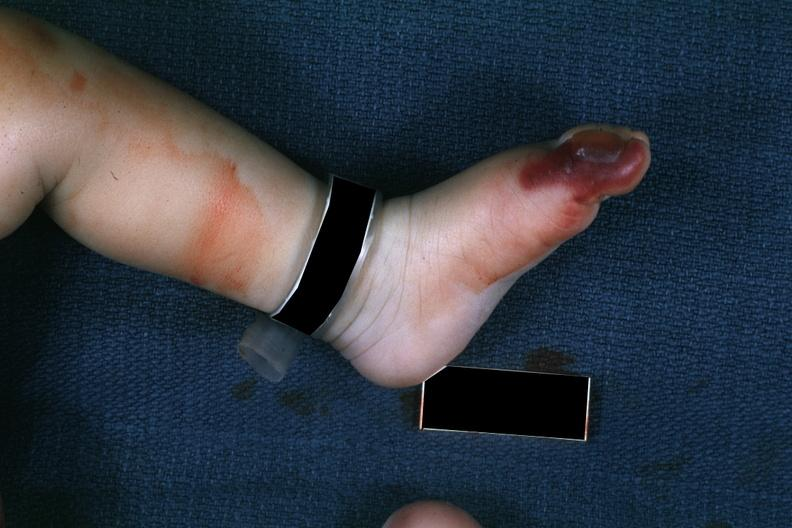how does this image show 1 month old child?
Answer the question using a single word or phrase. With congenital aortic stenosis 